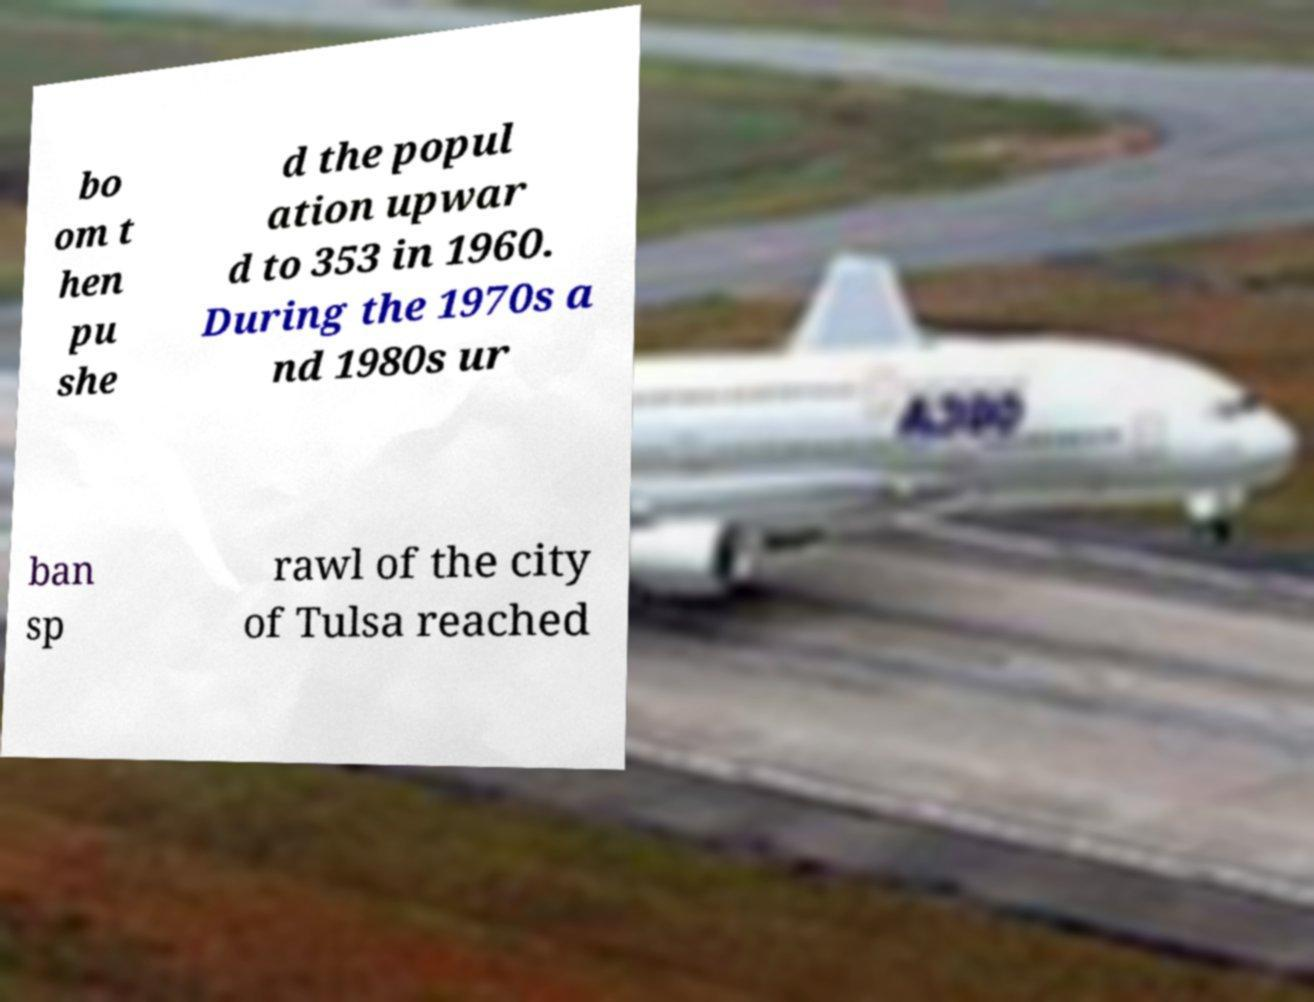Could you assist in decoding the text presented in this image and type it out clearly? bo om t hen pu she d the popul ation upwar d to 353 in 1960. During the 1970s a nd 1980s ur ban sp rawl of the city of Tulsa reached 